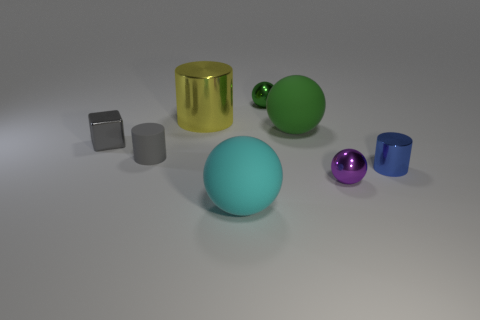Subtract all tiny cylinders. How many cylinders are left? 1 Subtract 1 cylinders. How many cylinders are left? 2 Subtract all cyan spheres. How many spheres are left? 3 Subtract all yellow balls. Subtract all green cylinders. How many balls are left? 4 Add 1 big green rubber things. How many objects exist? 9 Subtract all blocks. How many objects are left? 7 Add 5 shiny blocks. How many shiny blocks exist? 6 Subtract 0 red blocks. How many objects are left? 8 Subtract all tiny blue metal cubes. Subtract all small gray matte cylinders. How many objects are left? 7 Add 3 rubber cylinders. How many rubber cylinders are left? 4 